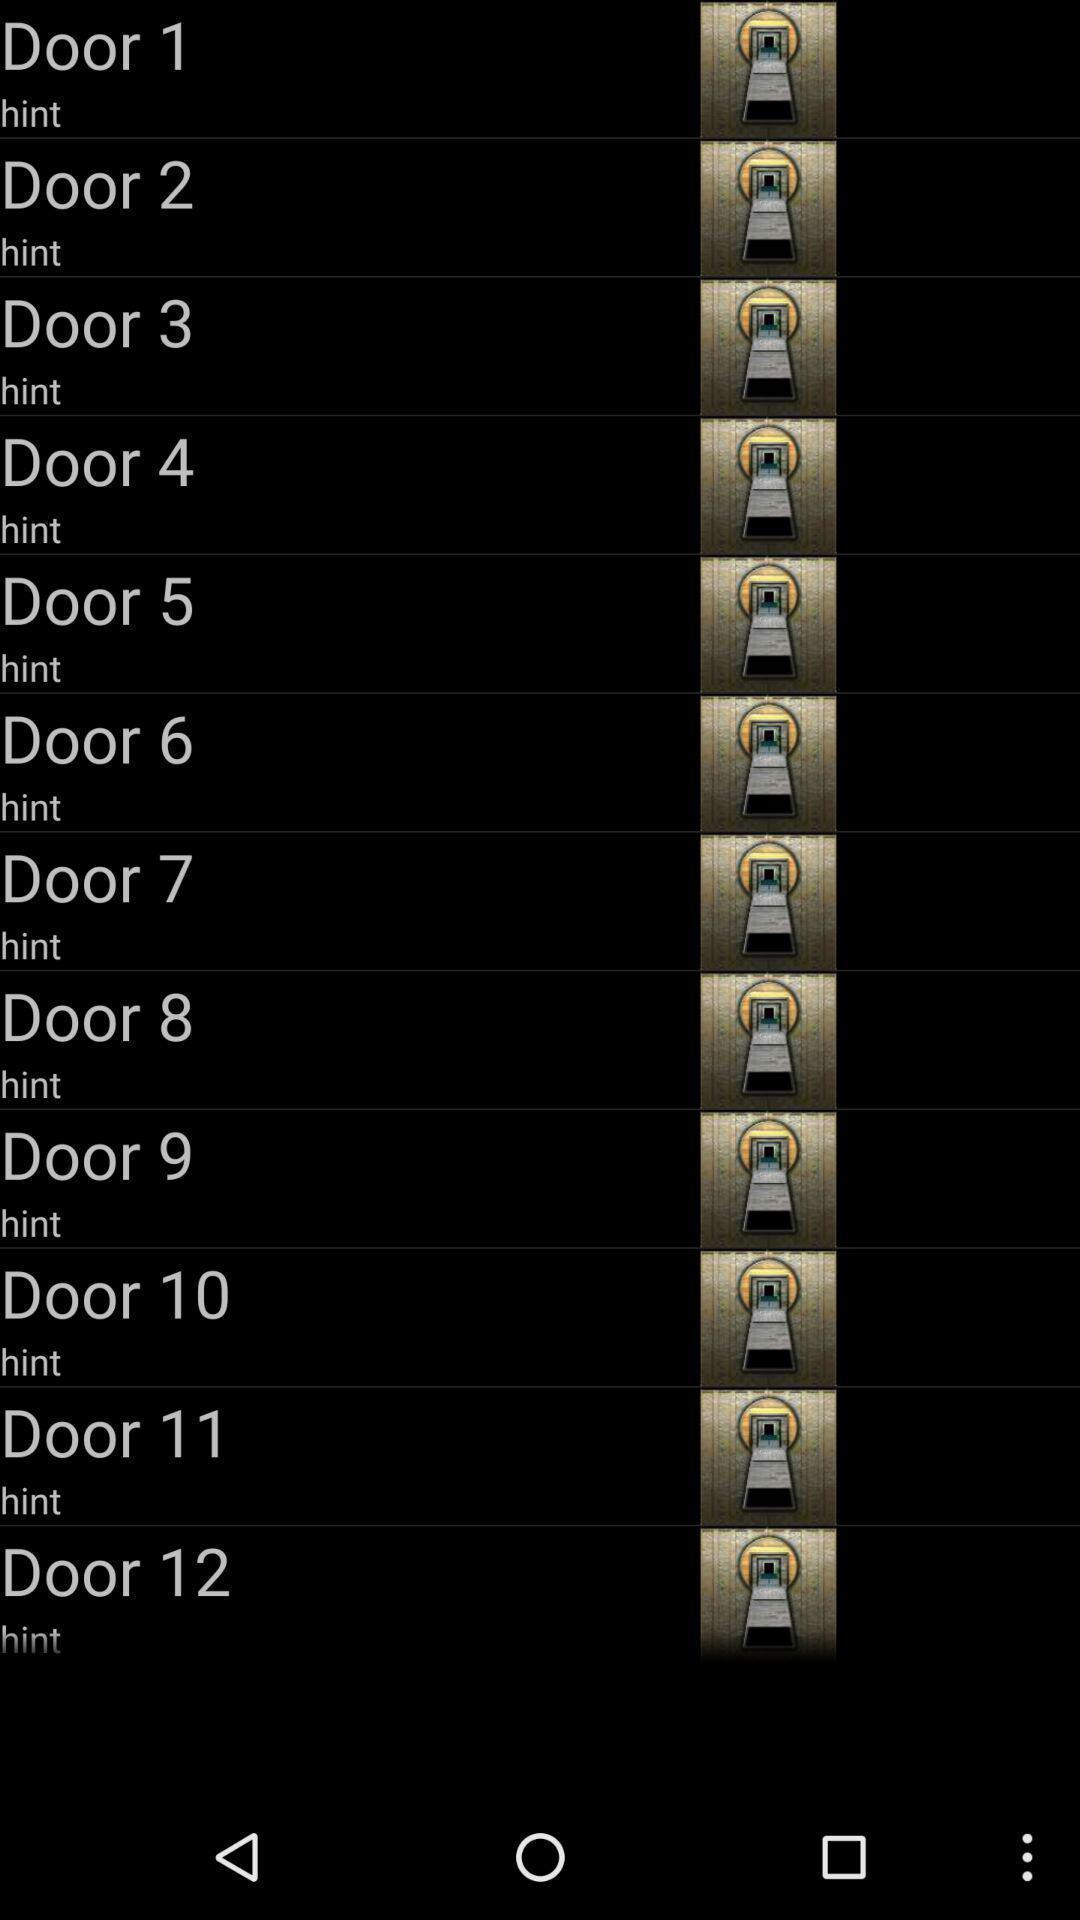Explain what's happening in this screen capture. Page is showing list of doors. 